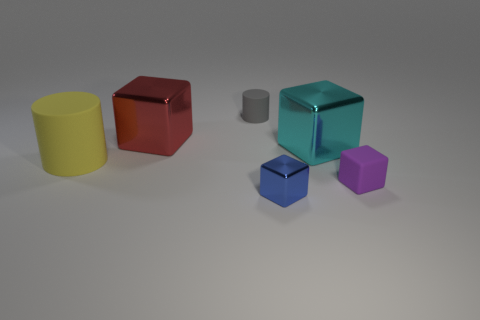Is the number of big red metal cubes behind the big red shiny thing the same as the number of shiny objects that are left of the big cyan metallic thing?
Offer a very short reply. No. Does the cylinder that is behind the big cylinder have the same material as the red cube?
Your answer should be very brief. No. There is a red cube that is the same size as the cyan block; what material is it?
Keep it short and to the point. Metal. What number of other objects are the same material as the blue object?
Give a very brief answer. 2. There is a red metallic cube; does it have the same size as the metal thing in front of the big yellow cylinder?
Ensure brevity in your answer.  No. Are there fewer tiny gray rubber things that are behind the big red metallic block than cubes right of the gray rubber cylinder?
Ensure brevity in your answer.  Yes. How big is the cube that is right of the large cyan metal object?
Your answer should be compact. Small. Do the cyan shiny cube and the blue metal thing have the same size?
Ensure brevity in your answer.  No. What number of blocks are behind the cyan metal cube and right of the cyan object?
Offer a terse response. 0. What number of yellow objects are small things or cylinders?
Your answer should be compact. 1. 